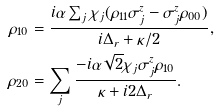Convert formula to latex. <formula><loc_0><loc_0><loc_500><loc_500>\rho _ { 1 0 } & = \frac { i \alpha \sum _ { j } \chi _ { j } ( \rho _ { 1 1 } \sigma _ { j } ^ { z } - \sigma _ { j } ^ { z } \rho _ { 0 0 } ) } { i \Delta _ { r } + \kappa / 2 } , \\ \rho _ { 2 0 } & = \sum _ { j } \frac { - i \alpha \sqrt { 2 } \chi _ { j } \sigma _ { j } ^ { z } \rho _ { 1 0 } } { \kappa + i 2 \Delta _ { r } } .</formula> 